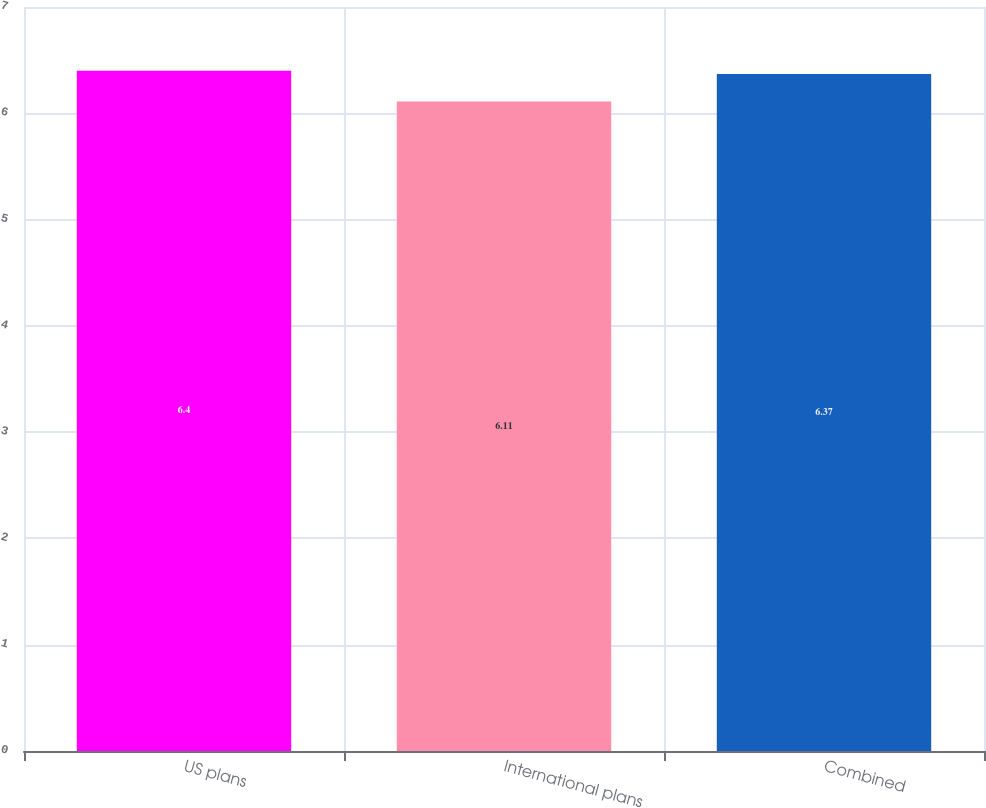<chart> <loc_0><loc_0><loc_500><loc_500><bar_chart><fcel>US plans<fcel>International plans<fcel>Combined<nl><fcel>6.4<fcel>6.11<fcel>6.37<nl></chart> 